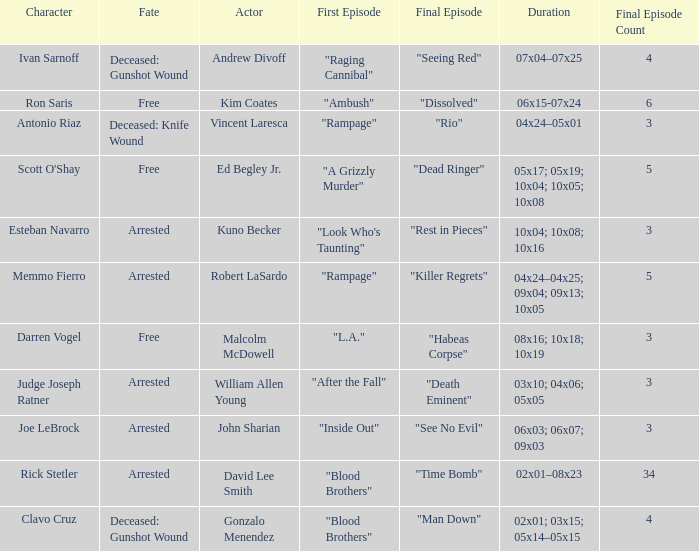What's the actor with character being judge joseph ratner William Allen Young. 